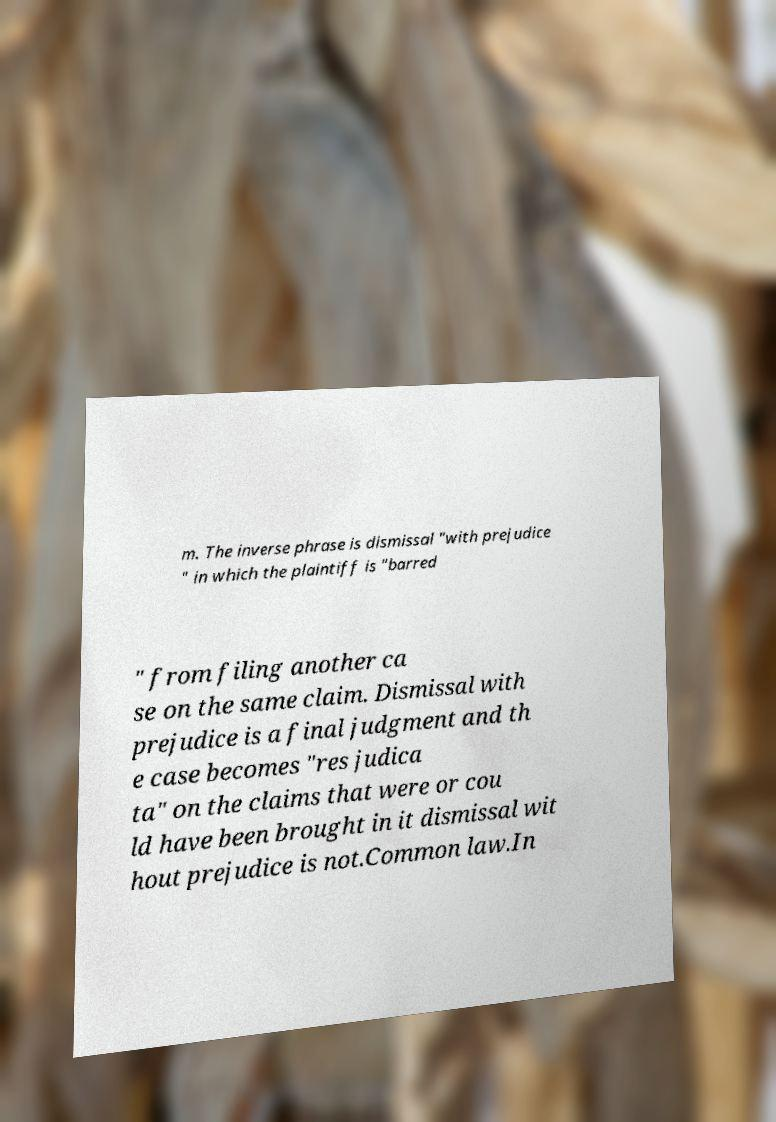There's text embedded in this image that I need extracted. Can you transcribe it verbatim? m. The inverse phrase is dismissal "with prejudice " in which the plaintiff is "barred " from filing another ca se on the same claim. Dismissal with prejudice is a final judgment and th e case becomes "res judica ta" on the claims that were or cou ld have been brought in it dismissal wit hout prejudice is not.Common law.In 